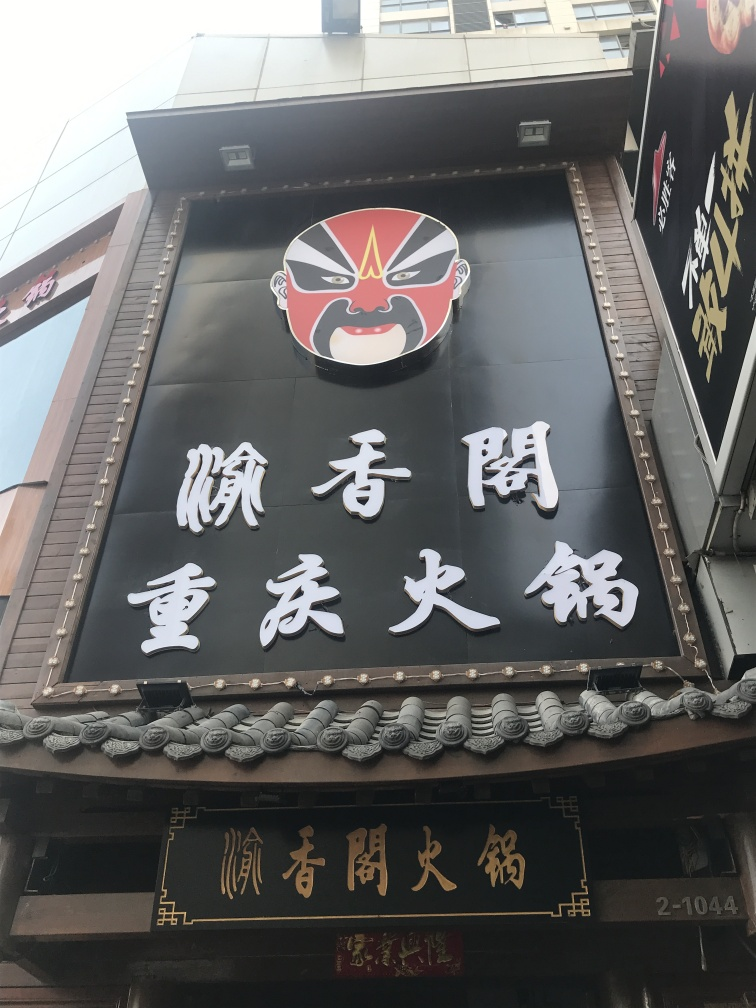Are the texts on the wall clear and visible? Yes, the texts on the wall are clear and prominently visible. They appear to be written in a bold white font on a dark background, which provides a strong contrast that makes them stand out. Furthermore, the typography and size of the characters suggest that they are meant to attract the attention of passersby, likely serving as signage for a business or establishment. 